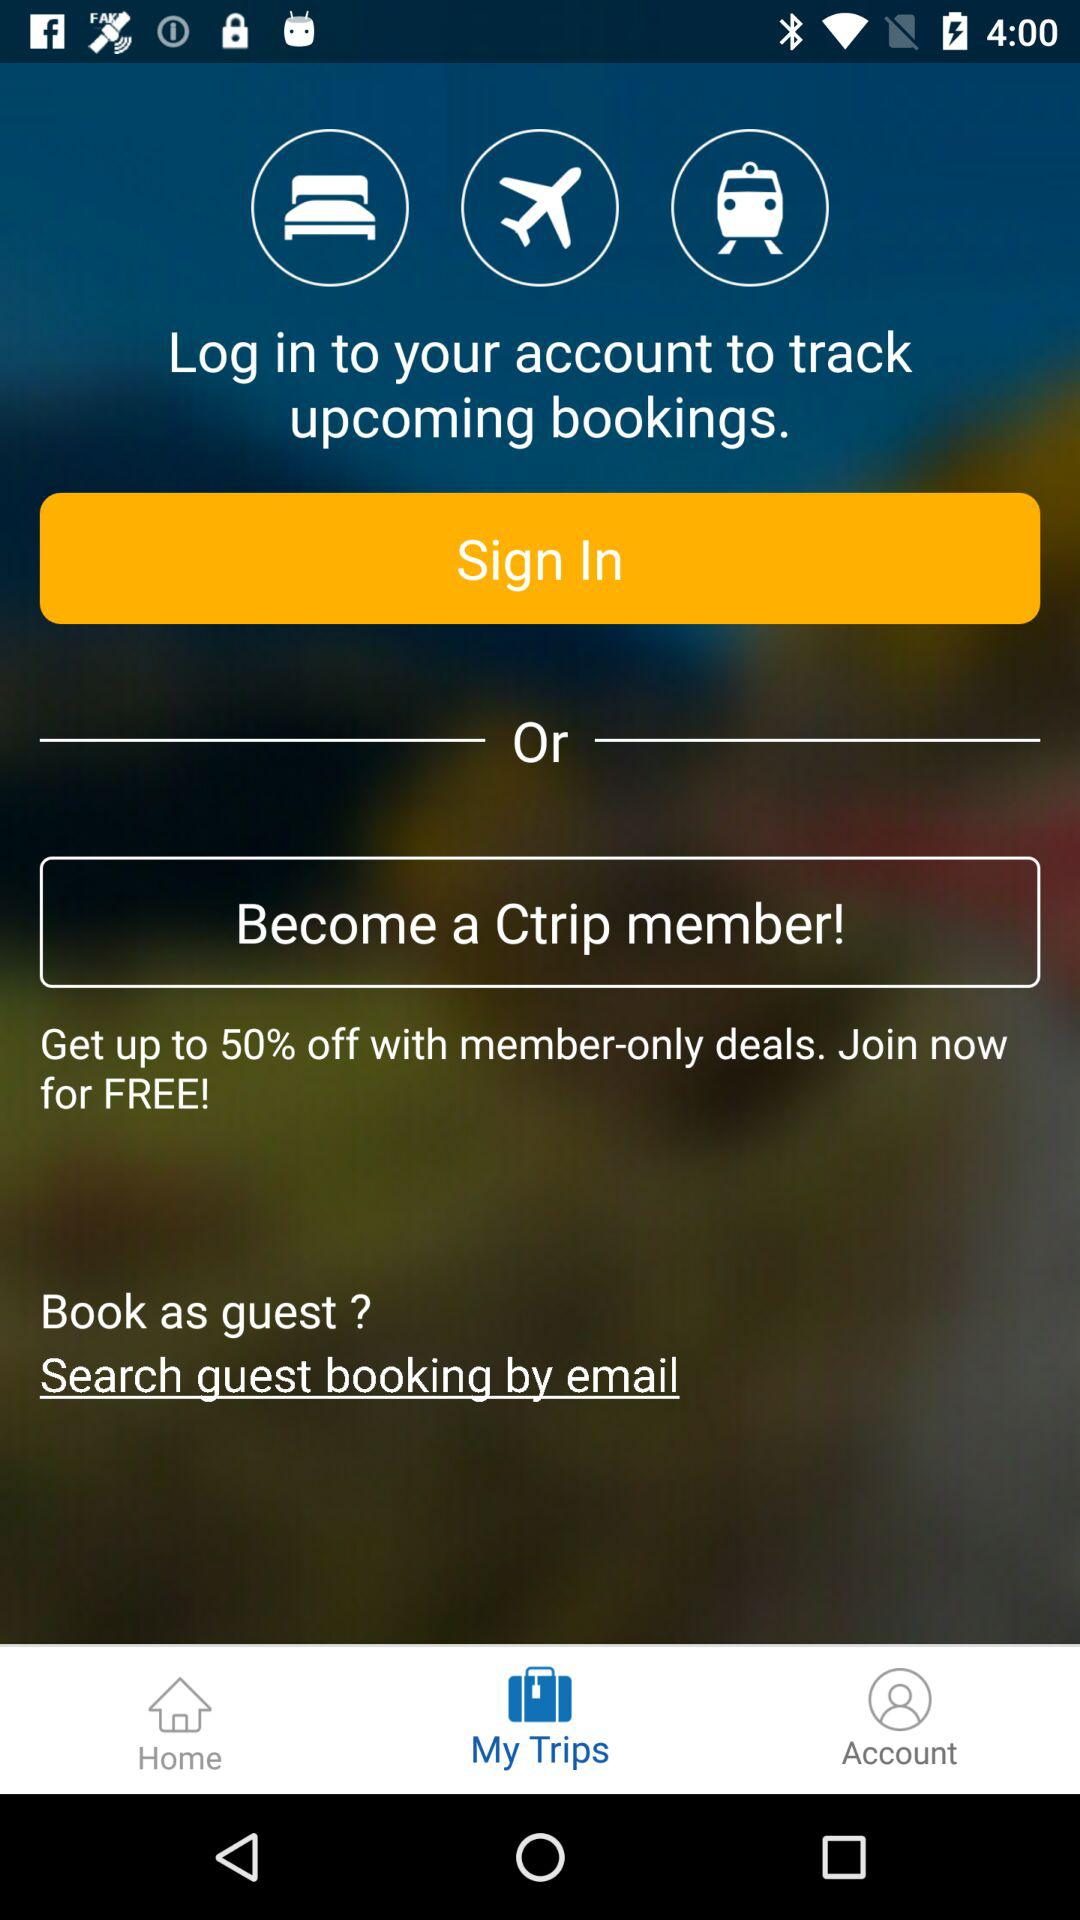Which tab is selected? The selected tab is "My Trips". 